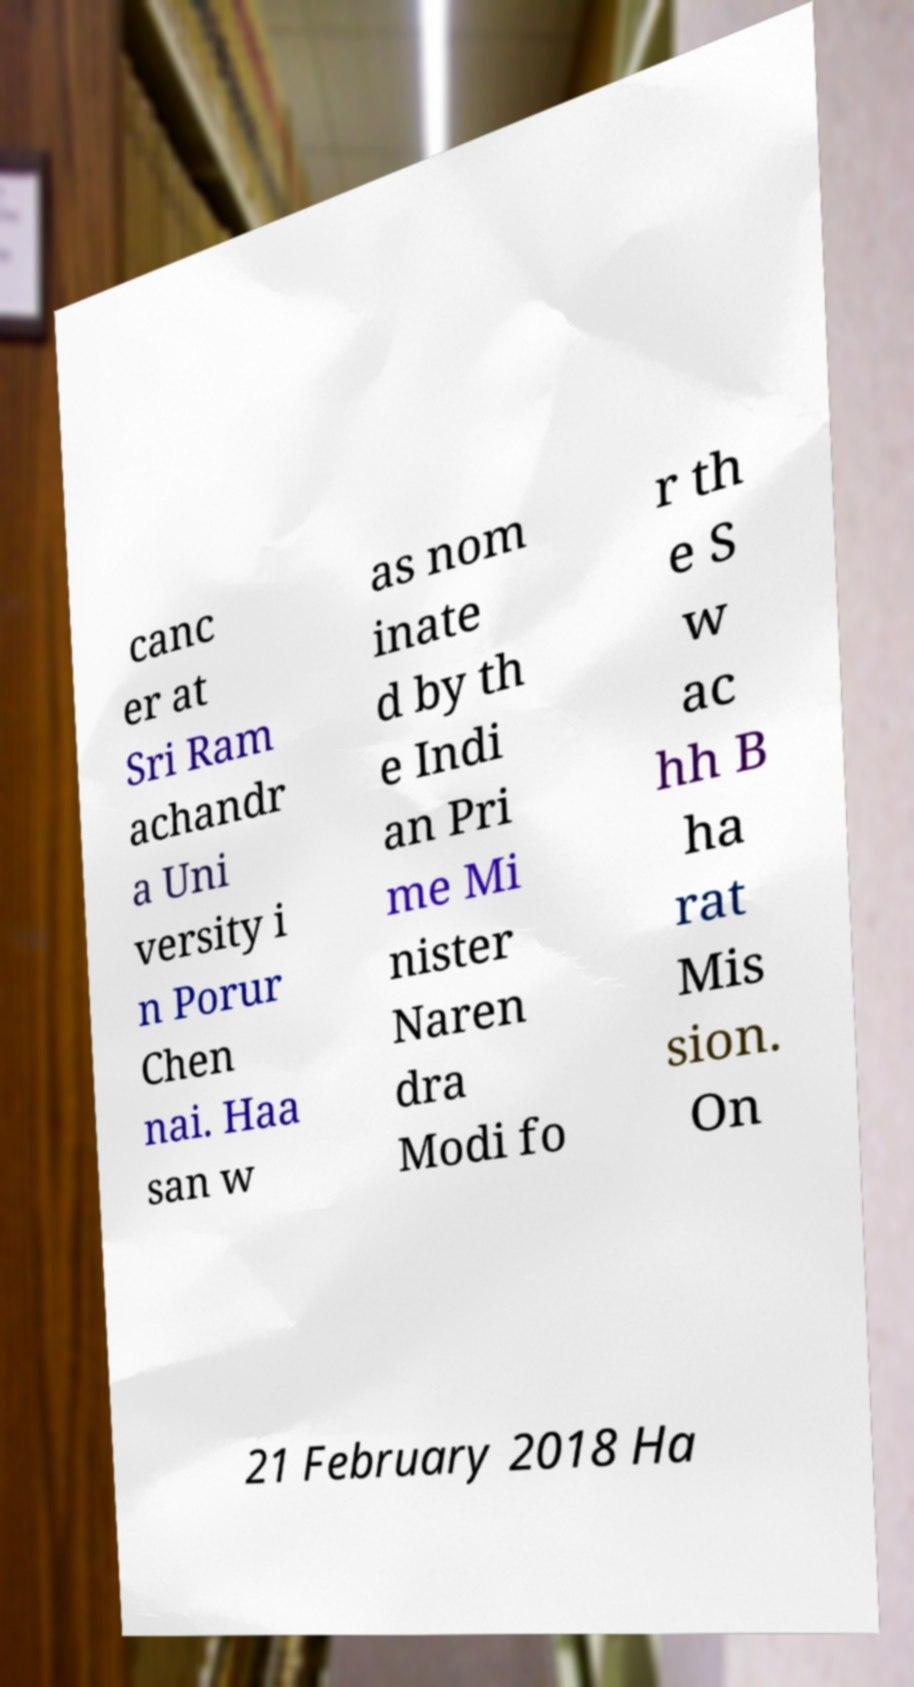Please read and relay the text visible in this image. What does it say? canc er at Sri Ram achandr a Uni versity i n Porur Chen nai. Haa san w as nom inate d by th e Indi an Pri me Mi nister Naren dra Modi fo r th e S w ac hh B ha rat Mis sion. On 21 February 2018 Ha 